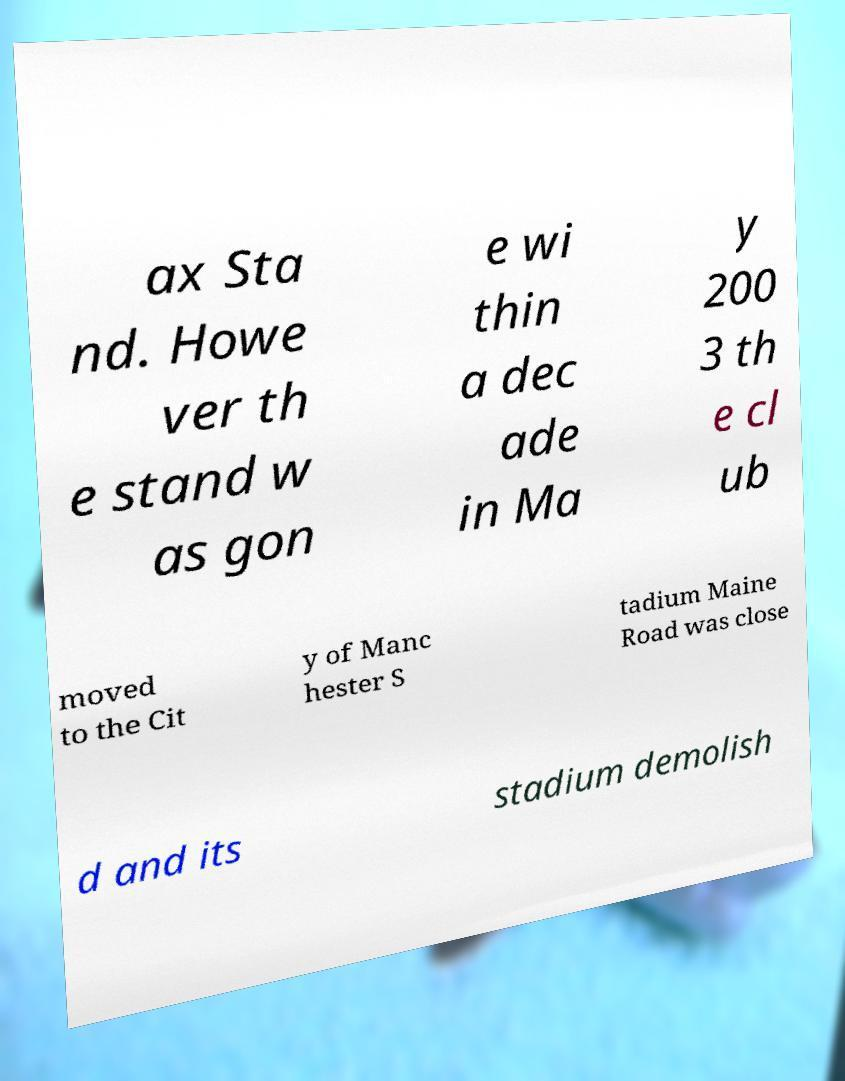I need the written content from this picture converted into text. Can you do that? ax Sta nd. Howe ver th e stand w as gon e wi thin a dec ade in Ma y 200 3 th e cl ub moved to the Cit y of Manc hester S tadium Maine Road was close d and its stadium demolish 